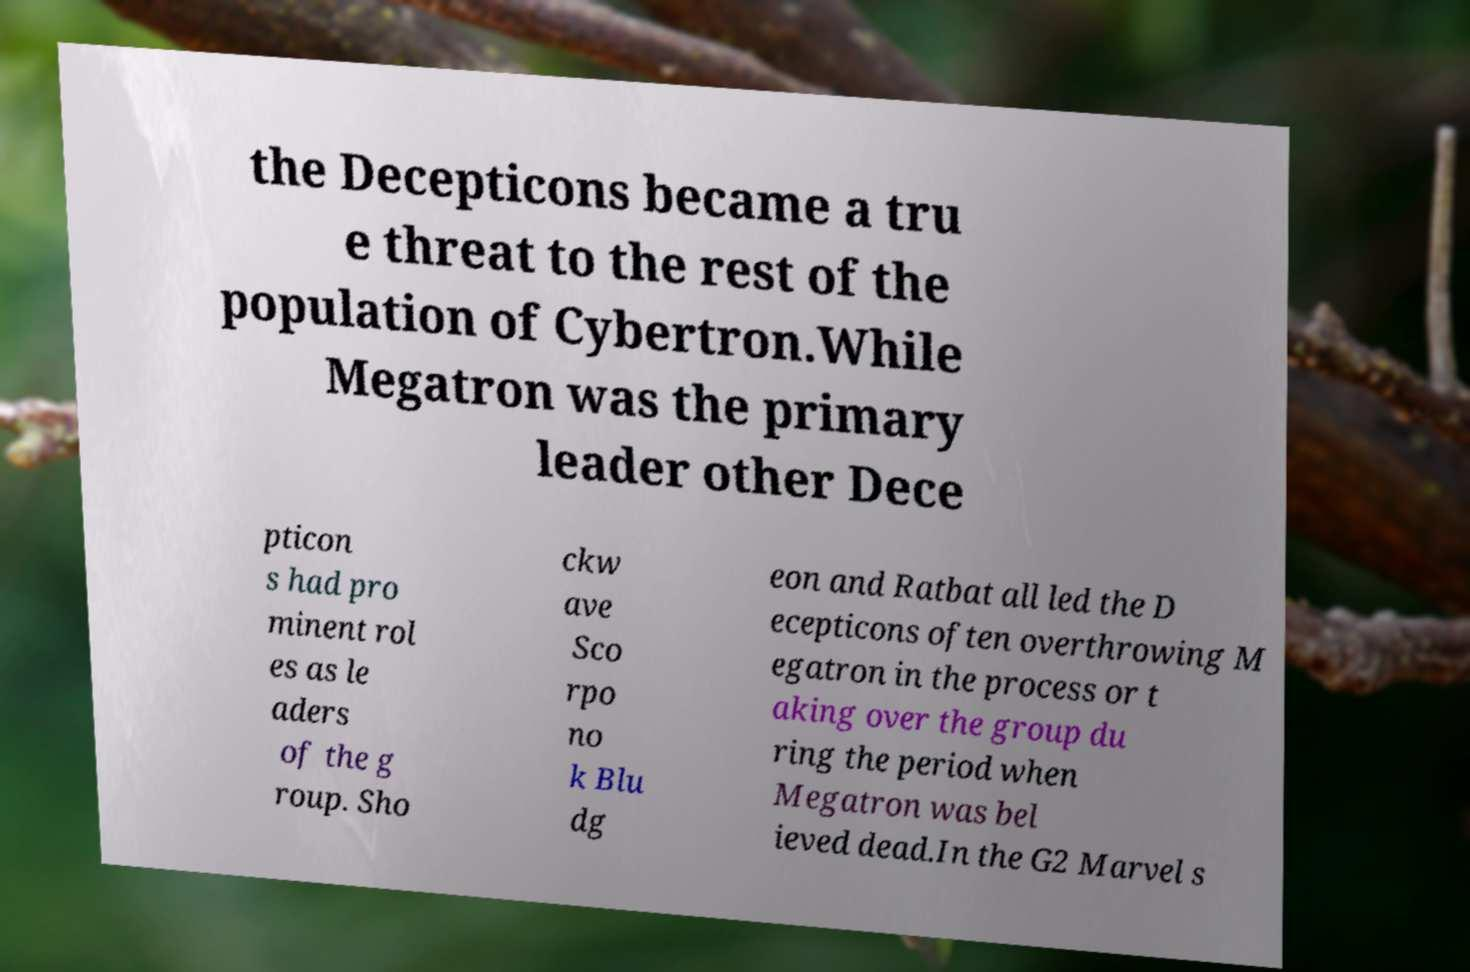Could you assist in decoding the text presented in this image and type it out clearly? the Decepticons became a tru e threat to the rest of the population of Cybertron.While Megatron was the primary leader other Dece pticon s had pro minent rol es as le aders of the g roup. Sho ckw ave Sco rpo no k Blu dg eon and Ratbat all led the D ecepticons often overthrowing M egatron in the process or t aking over the group du ring the period when Megatron was bel ieved dead.In the G2 Marvel s 